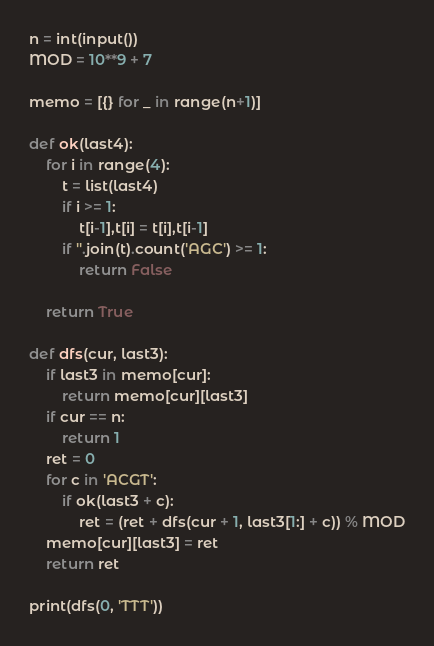Convert code to text. <code><loc_0><loc_0><loc_500><loc_500><_Python_>n = int(input())
MOD = 10**9 + 7

memo = [{} for _ in range(n+1)]

def ok(last4):
    for i in range(4):
        t = list(last4)
        if i >= 1:
            t[i-1],t[i] = t[i],t[i-1]
        if ''.join(t).count('AGC') >= 1:
            return False

    return True

def dfs(cur, last3):
    if last3 in memo[cur]:
        return memo[cur][last3]
    if cur == n:
        return 1
    ret = 0
    for c in 'ACGT':
        if ok(last3 + c):
            ret = (ret + dfs(cur + 1, last3[1:] + c)) % MOD
    memo[cur][last3] = ret
    return ret

print(dfs(0, 'TTT'))</code> 